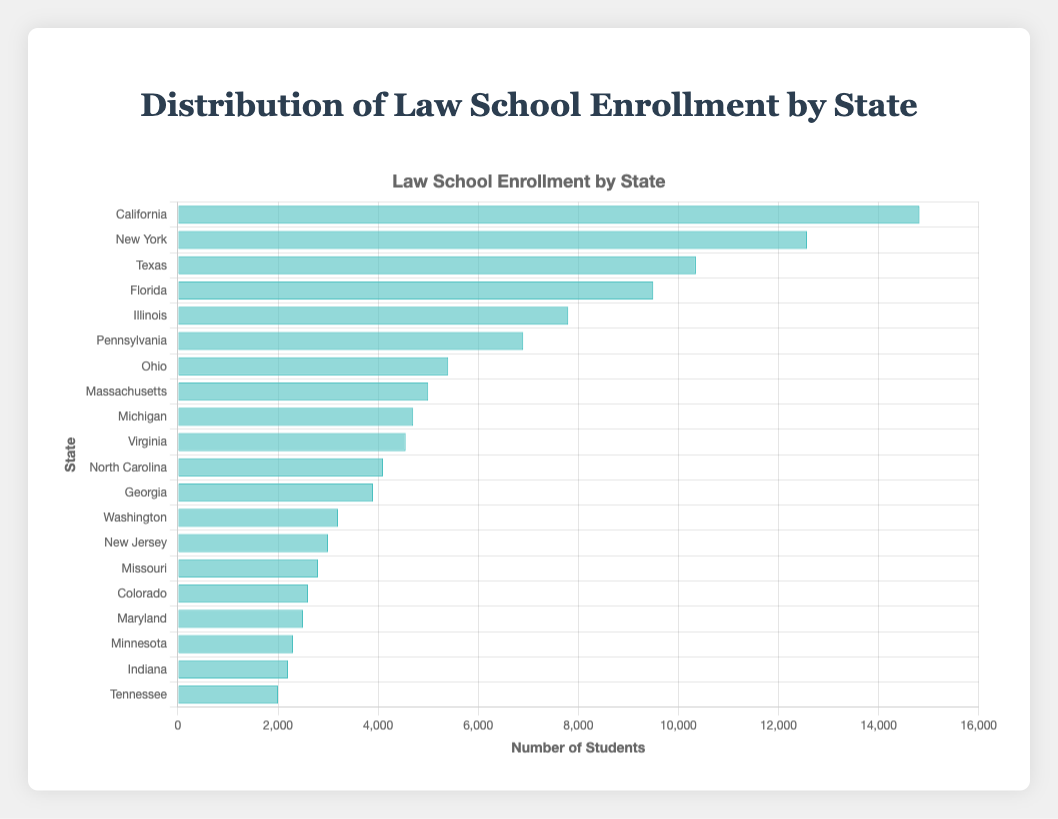Which state has the highest law school enrollment? By comparing the length of the bars, California has the longest bar, indicating the highest enrollment.
Answer: California Which state has the lowest law school enrollment? By comparing the length of the bars, Tennessee has the shortest bar, indicating the lowest enrollment.
Answer: Tennessee How much higher is California's law school enrollment compared to Texas? California's enrollment is 14,820, and Texas's enrollment is 10,350. The difference is 14,820 - 10,350 = 4,470.
Answer: 4,470 What is the total law school enrollment for the top three states? The top three states are California (14,820), New York (12,570), and Texas (10,350). The total is 14,820 + 12,570 + 10,350 = 37,740.
Answer: 37,740 Which states have a law school enrollment greater than 10,000? Examining the bars, California (14,820), New York (12,570), and Texas (10,350) have enrollments greater than 10,000.
Answer: California, New York, Texas Is the law school enrollment of Florida greater than that of Illinois and Pennsylvania combined? Florida's enrollment is 9,500. Illinois and Pennsylvania have enrollments of 7,800 and 6,900, respectively. The combined enrollment is 7,800 + 6,900 = 14,700. Since 9,500 < 14,700, Florida's enrollment is not greater.
Answer: No What is the average law school enrollment among all listed states? Total enrollment is the sum of all states' enrollments: 14820 + 12570 + 10350 + 9500 + 7800 + 6900 + 5400 + 5000 + 4700 + 4550 + 4100 + 3900 + 3200 + 3000 + 2800 + 2600 + 2500 + 2300 + 2200 + 2000 = 104,960. There are 20 states, so the average is 104,960/20 = 5,248.
Answer: 5,248 What is the median law school enrollment among the listed states? Listing enrollments in ascending order: 2000, 2200, 2300, 2500, 2600, 2800, 3000, 3200, 3900, 4100, 4550, 4700, 5000, 5400, 6900, 7800, 9500, 10350, 12570, 14820. The median is the average of the 10th and 11th values: (4100 + 4550)/2 = 4,325.
Answer: 4,325 How does the enrollment of Massachusetts compare to that of Michigan and Virginia combined? Massachusetts has an enrollment of 5,000. Michigan and Virginia have enrollments of 4,700 and 4,550, respectively. The combined enrollment is 4,700 + 4,550 = 9,250. Since 5,000 < 9,250, Massachusetts's enrollment is less.
Answer: Less 